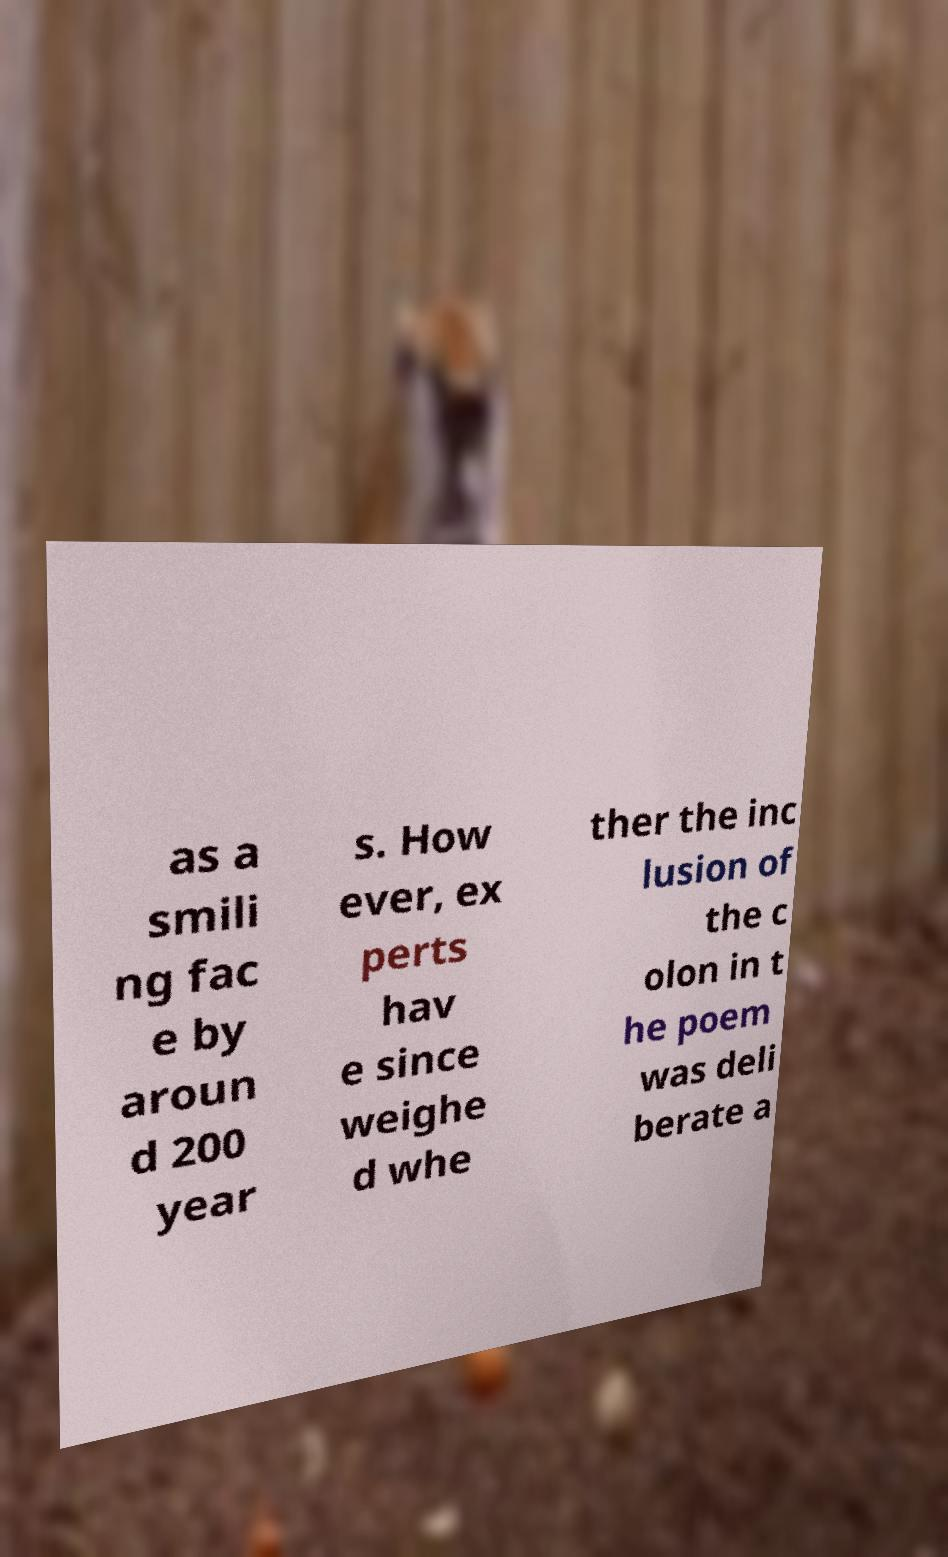Can you read and provide the text displayed in the image?This photo seems to have some interesting text. Can you extract and type it out for me? as a smili ng fac e by aroun d 200 year s. How ever, ex perts hav e since weighe d whe ther the inc lusion of the c olon in t he poem was deli berate a 